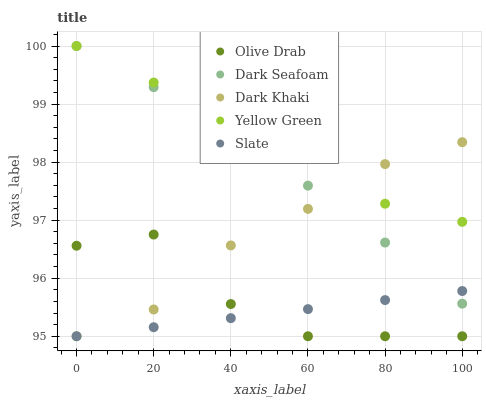Does Slate have the minimum area under the curve?
Answer yes or no. Yes. Does Yellow Green have the maximum area under the curve?
Answer yes or no. Yes. Does Dark Seafoam have the minimum area under the curve?
Answer yes or no. No. Does Dark Seafoam have the maximum area under the curve?
Answer yes or no. No. Is Slate the smoothest?
Answer yes or no. Yes. Is Olive Drab the roughest?
Answer yes or no. Yes. Is Dark Seafoam the smoothest?
Answer yes or no. No. Is Dark Seafoam the roughest?
Answer yes or no. No. Does Dark Khaki have the lowest value?
Answer yes or no. Yes. Does Dark Seafoam have the lowest value?
Answer yes or no. No. Does Yellow Green have the highest value?
Answer yes or no. Yes. Does Slate have the highest value?
Answer yes or no. No. Is Slate less than Yellow Green?
Answer yes or no. Yes. Is Dark Seafoam greater than Olive Drab?
Answer yes or no. Yes. Does Olive Drab intersect Slate?
Answer yes or no. Yes. Is Olive Drab less than Slate?
Answer yes or no. No. Is Olive Drab greater than Slate?
Answer yes or no. No. Does Slate intersect Yellow Green?
Answer yes or no. No. 